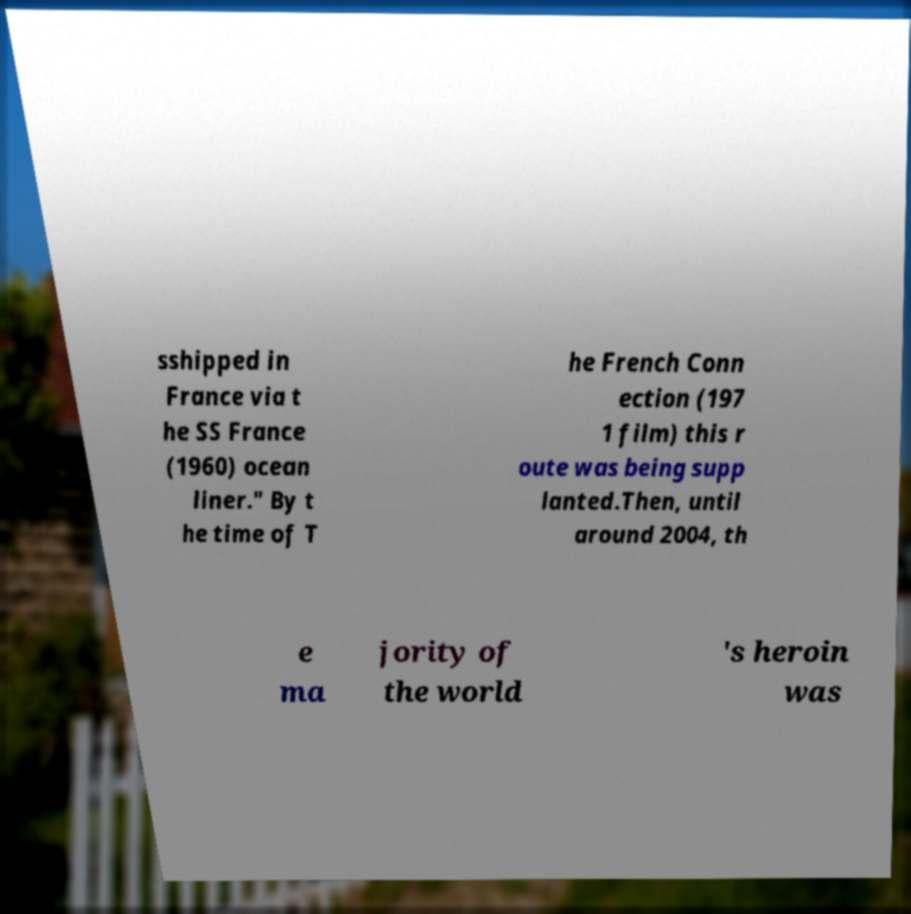What messages or text are displayed in this image? I need them in a readable, typed format. sshipped in France via t he SS France (1960) ocean liner." By t he time of T he French Conn ection (197 1 film) this r oute was being supp lanted.Then, until around 2004, th e ma jority of the world 's heroin was 